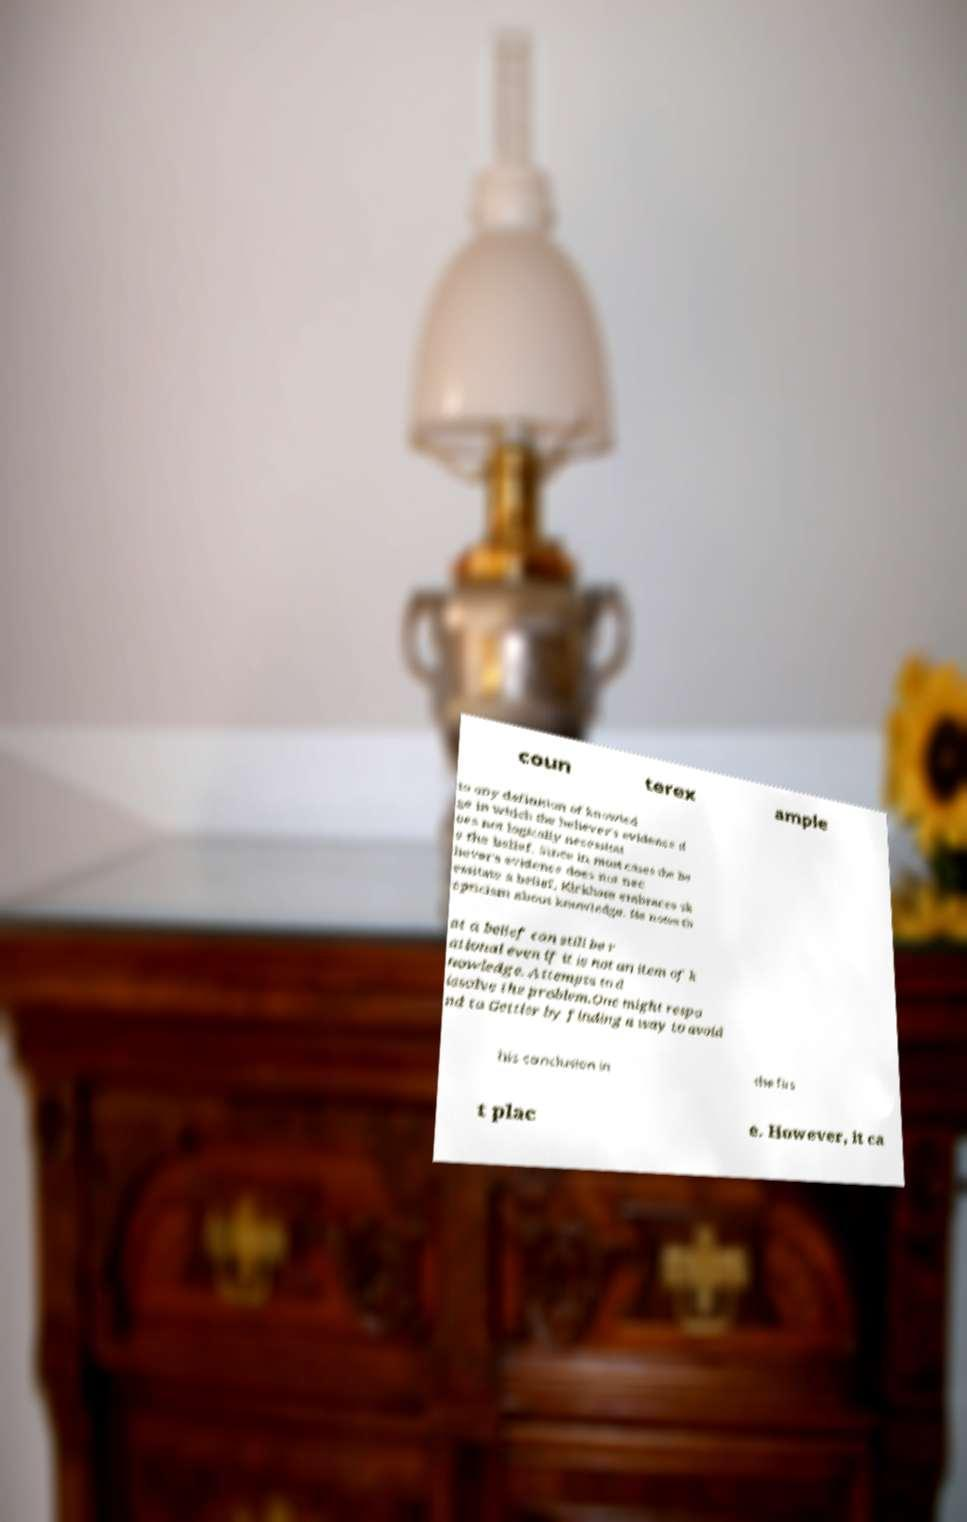Please read and relay the text visible in this image. What does it say? coun terex ample to any definition of knowled ge in which the believer's evidence d oes not logically necessitat e the belief. Since in most cases the be liever's evidence does not nec essitate a belief, Kirkham embraces sk epticism about knowledge. He notes th at a belief can still be r ational even if it is not an item of k nowledge. Attempts to d issolve the problem.One might respo nd to Gettier by finding a way to avoid his conclusion in the firs t plac e. However, it ca 